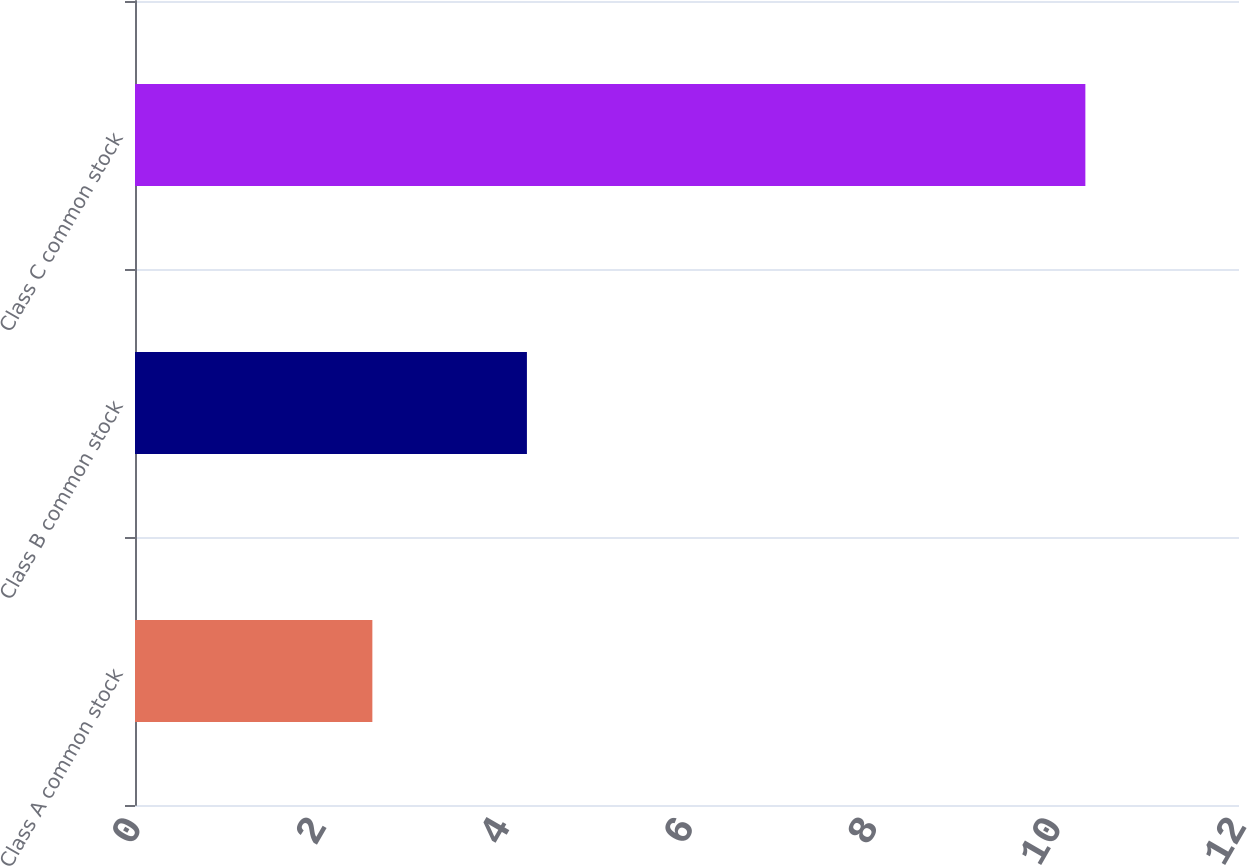Convert chart to OTSL. <chart><loc_0><loc_0><loc_500><loc_500><bar_chart><fcel>Class A common stock<fcel>Class B common stock<fcel>Class C common stock<nl><fcel>2.58<fcel>4.26<fcel>10.33<nl></chart> 